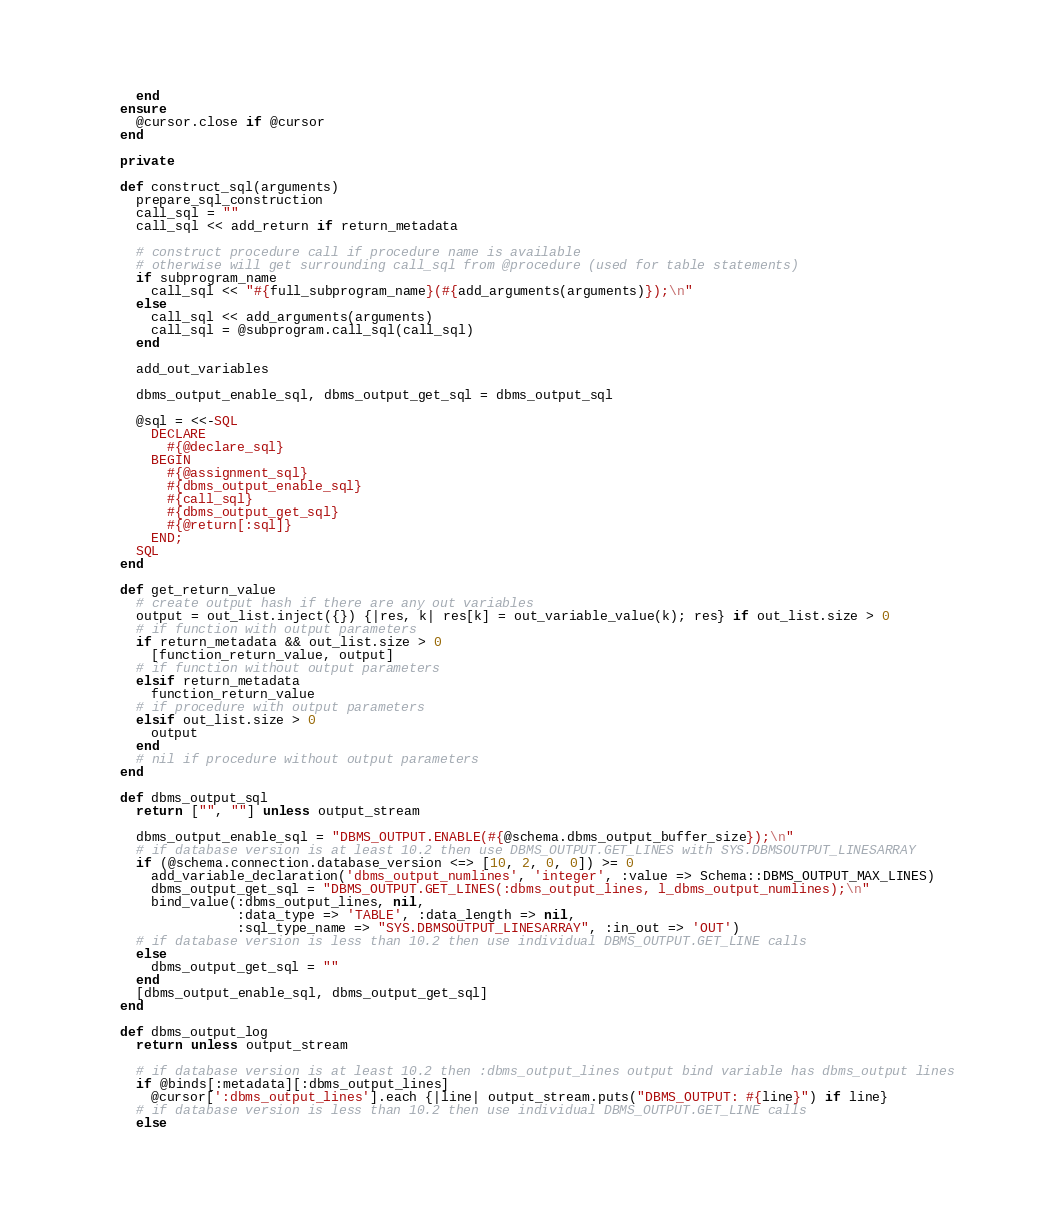<code> <loc_0><loc_0><loc_500><loc_500><_Ruby_>      end
    ensure
      @cursor.close if @cursor
    end

    private

    def construct_sql(arguments)
      prepare_sql_construction
      call_sql = ""
      call_sql << add_return if return_metadata

      # construct procedure call if procedure name is available
      # otherwise will get surrounding call_sql from @procedure (used for table statements)
      if subprogram_name
        call_sql << "#{full_subprogram_name}(#{add_arguments(arguments)});\n"
      else
        call_sql << add_arguments(arguments)
        call_sql = @subprogram.call_sql(call_sql)
      end

      add_out_variables

      dbms_output_enable_sql, dbms_output_get_sql = dbms_output_sql

      @sql = <<-SQL
        DECLARE
          #{@declare_sql}
        BEGIN
          #{@assignment_sql}
          #{dbms_output_enable_sql}
          #{call_sql}
          #{dbms_output_get_sql}
          #{@return[:sql]}
        END;
      SQL
    end

    def get_return_value
      # create output hash if there are any out variables
      output = out_list.inject({}) {|res, k| res[k] = out_variable_value(k); res} if out_list.size > 0
      # if function with output parameters
      if return_metadata && out_list.size > 0
        [function_return_value, output]
      # if function without output parameters
      elsif return_metadata
        function_return_value
      # if procedure with output parameters
      elsif out_list.size > 0
        output
      end
      # nil if procedure without output parameters
    end

    def dbms_output_sql
      return ["", ""] unless output_stream

      dbms_output_enable_sql = "DBMS_OUTPUT.ENABLE(#{@schema.dbms_output_buffer_size});\n"
      # if database version is at least 10.2 then use DBMS_OUTPUT.GET_LINES with SYS.DBMSOUTPUT_LINESARRAY
      if (@schema.connection.database_version <=> [10, 2, 0, 0]) >= 0
        add_variable_declaration('dbms_output_numlines', 'integer', :value => Schema::DBMS_OUTPUT_MAX_LINES)
        dbms_output_get_sql = "DBMS_OUTPUT.GET_LINES(:dbms_output_lines, l_dbms_output_numlines);\n"
        bind_value(:dbms_output_lines, nil,
                   :data_type => 'TABLE', :data_length => nil,
                   :sql_type_name => "SYS.DBMSOUTPUT_LINESARRAY", :in_out => 'OUT')
      # if database version is less than 10.2 then use individual DBMS_OUTPUT.GET_LINE calls
      else
        dbms_output_get_sql = ""
      end
      [dbms_output_enable_sql, dbms_output_get_sql]
    end

    def dbms_output_log
      return unless output_stream

      # if database version is at least 10.2 then :dbms_output_lines output bind variable has dbms_output lines
      if @binds[:metadata][:dbms_output_lines]
        @cursor[':dbms_output_lines'].each {|line| output_stream.puts("DBMS_OUTPUT: #{line}") if line}
      # if database version is less than 10.2 then use individual DBMS_OUTPUT.GET_LINE calls
      else</code> 